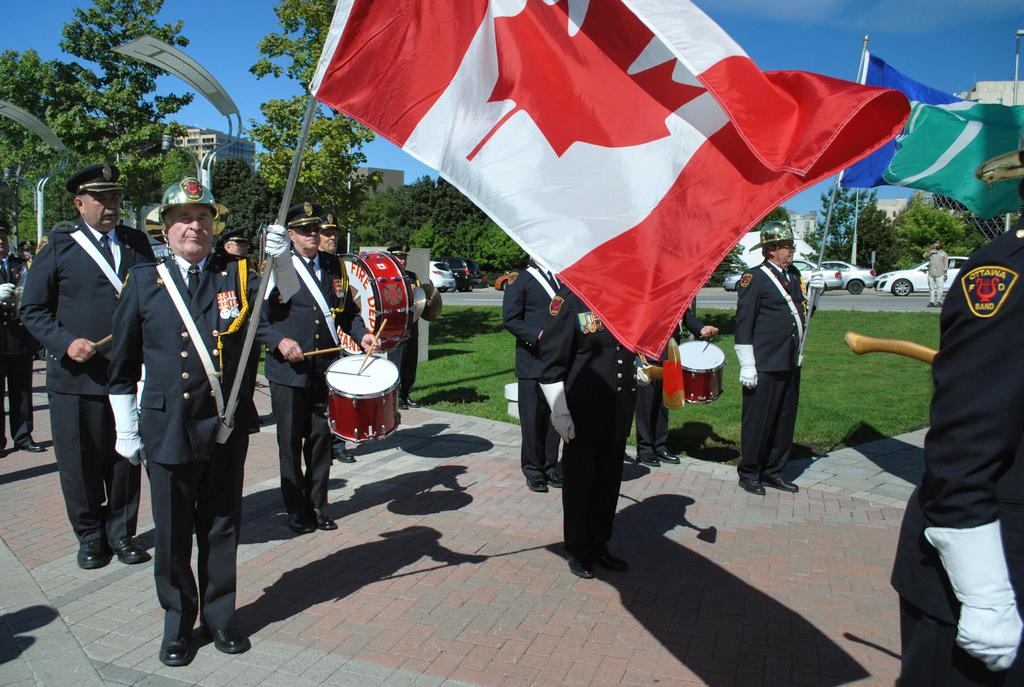What are the people in the image doing? Some people are holding flags in their hands, and some are playing drums. Can you describe the background of the image? There are trees and vehicles on a road in the background of the image. How many rabbits can be seen holding flags in the image? There are no rabbits present in the image, and therefore none are holding flags. 